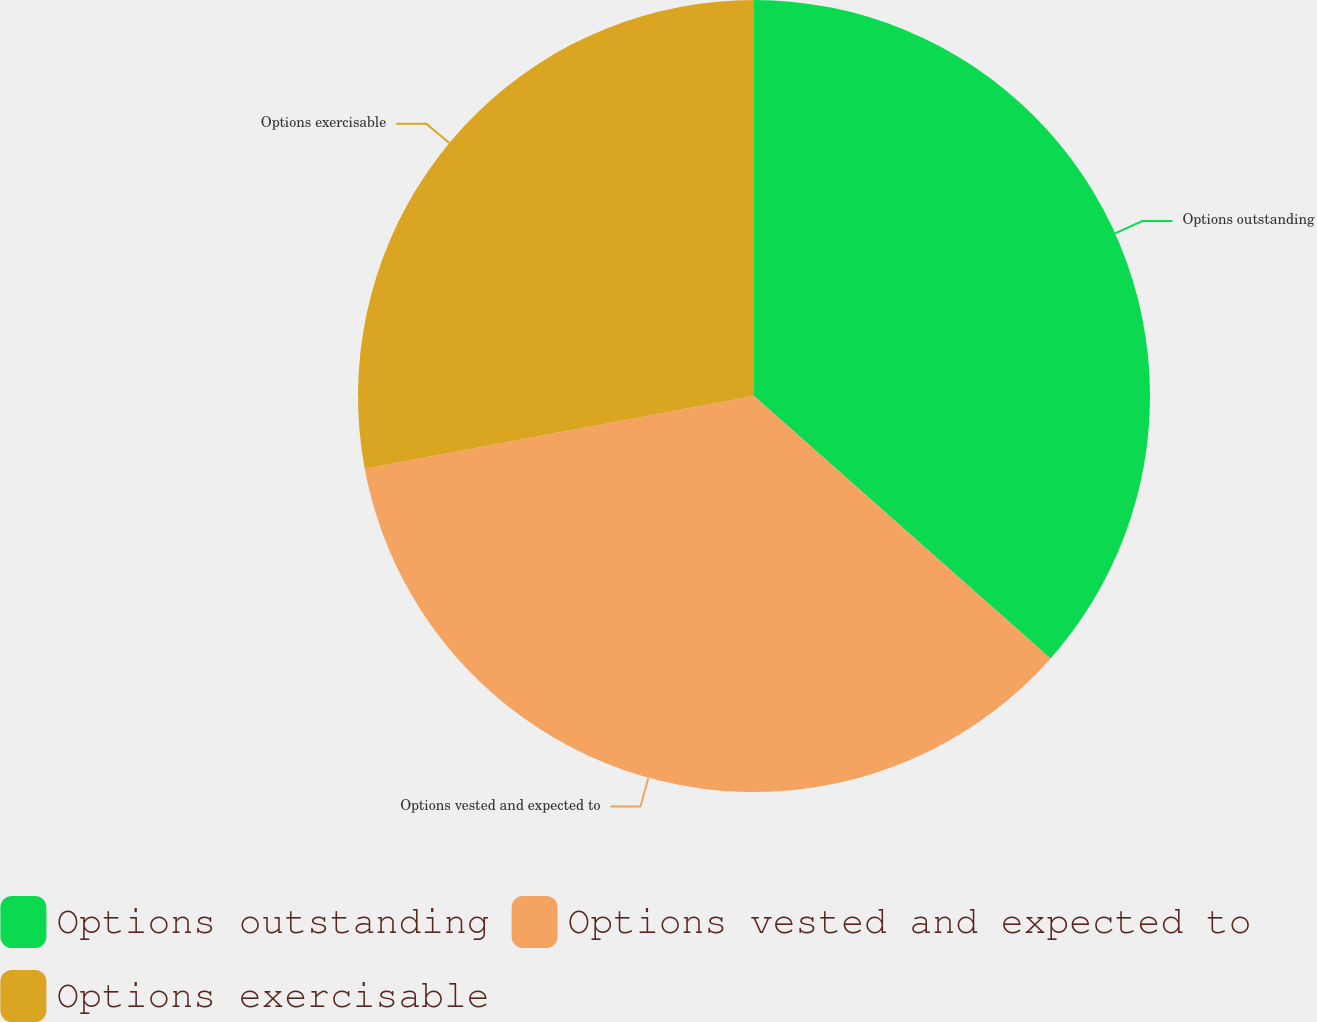Convert chart. <chart><loc_0><loc_0><loc_500><loc_500><pie_chart><fcel>Options outstanding<fcel>Options vested and expected to<fcel>Options exercisable<nl><fcel>36.53%<fcel>35.53%<fcel>27.94%<nl></chart> 